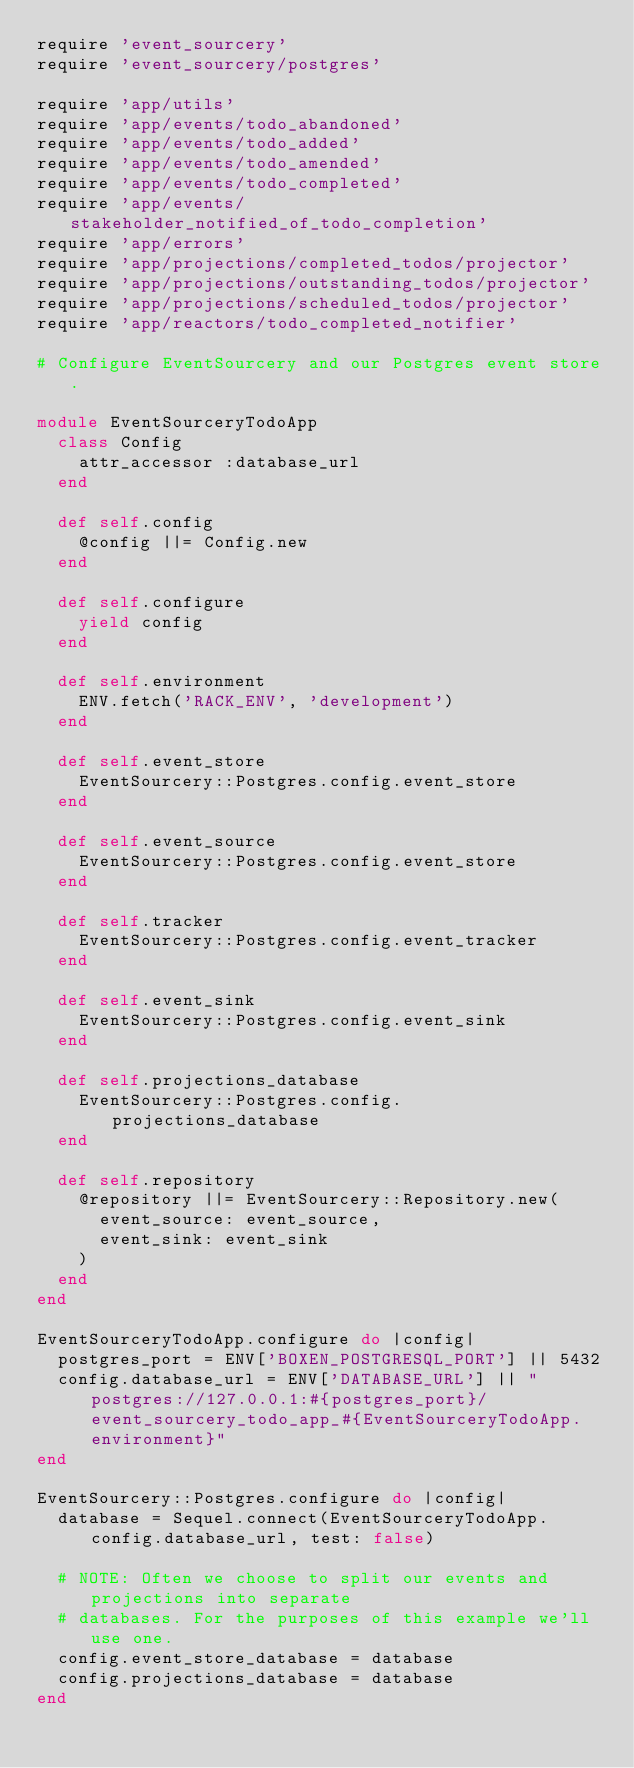<code> <loc_0><loc_0><loc_500><loc_500><_Ruby_>require 'event_sourcery'
require 'event_sourcery/postgres'

require 'app/utils'
require 'app/events/todo_abandoned'
require 'app/events/todo_added'
require 'app/events/todo_amended'
require 'app/events/todo_completed'
require 'app/events/stakeholder_notified_of_todo_completion'
require 'app/errors'
require 'app/projections/completed_todos/projector'
require 'app/projections/outstanding_todos/projector'
require 'app/projections/scheduled_todos/projector'
require 'app/reactors/todo_completed_notifier'

# Configure EventSourcery and our Postgres event store.

module EventSourceryTodoApp
  class Config
    attr_accessor :database_url
  end

  def self.config
    @config ||= Config.new
  end

  def self.configure
    yield config
  end

  def self.environment
    ENV.fetch('RACK_ENV', 'development')
  end

  def self.event_store
    EventSourcery::Postgres.config.event_store
  end

  def self.event_source
    EventSourcery::Postgres.config.event_store
  end

  def self.tracker
    EventSourcery::Postgres.config.event_tracker
  end

  def self.event_sink
    EventSourcery::Postgres.config.event_sink
  end

  def self.projections_database
    EventSourcery::Postgres.config.projections_database
  end

  def self.repository
    @repository ||= EventSourcery::Repository.new(
      event_source: event_source,
      event_sink: event_sink
    )
  end
end

EventSourceryTodoApp.configure do |config|
  postgres_port = ENV['BOXEN_POSTGRESQL_PORT'] || 5432
  config.database_url = ENV['DATABASE_URL'] || "postgres://127.0.0.1:#{postgres_port}/event_sourcery_todo_app_#{EventSourceryTodoApp.environment}"
end

EventSourcery::Postgres.configure do |config|
  database = Sequel.connect(EventSourceryTodoApp.config.database_url, test: false)

  # NOTE: Often we choose to split our events and projections into separate
  # databases. For the purposes of this example we'll use one.
  config.event_store_database = database
  config.projections_database = database
end
</code> 